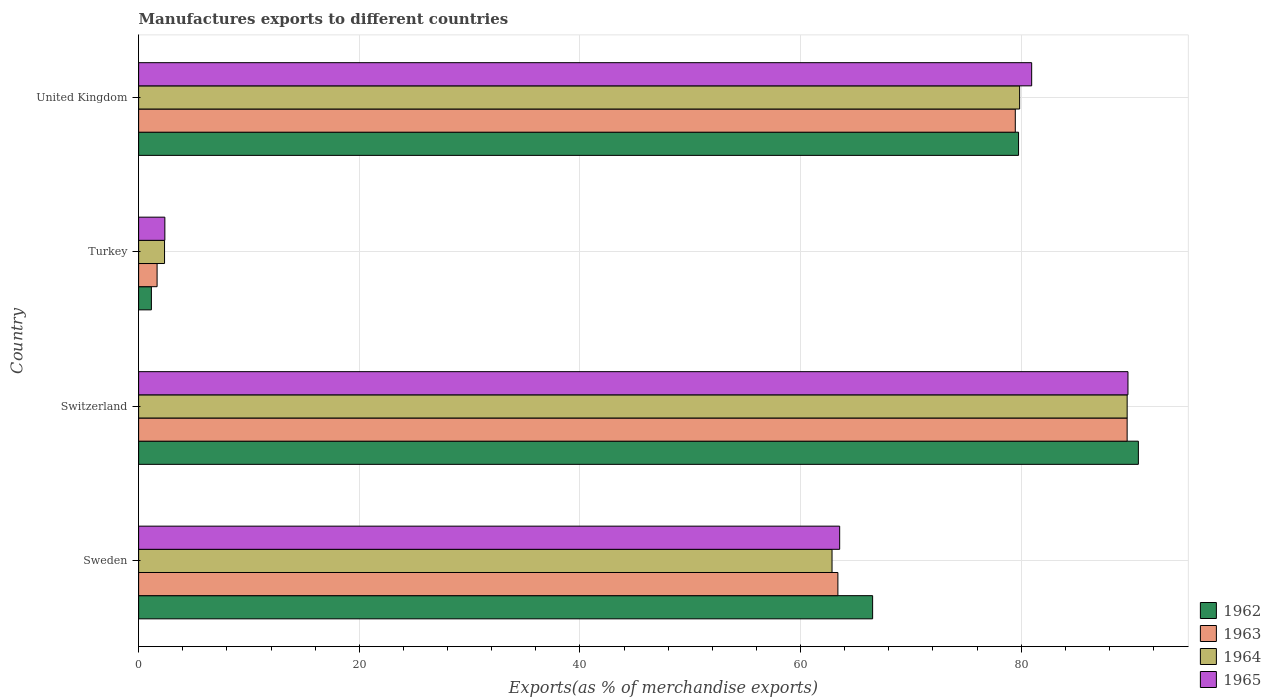How many different coloured bars are there?
Keep it short and to the point. 4. How many bars are there on the 1st tick from the top?
Ensure brevity in your answer.  4. How many bars are there on the 4th tick from the bottom?
Keep it short and to the point. 4. What is the label of the 4th group of bars from the top?
Offer a terse response. Sweden. In how many cases, is the number of bars for a given country not equal to the number of legend labels?
Provide a succinct answer. 0. What is the percentage of exports to different countries in 1965 in Switzerland?
Offer a very short reply. 89.68. Across all countries, what is the maximum percentage of exports to different countries in 1963?
Provide a short and direct response. 89.61. Across all countries, what is the minimum percentage of exports to different countries in 1962?
Your response must be concise. 1.16. In which country was the percentage of exports to different countries in 1965 maximum?
Provide a short and direct response. Switzerland. In which country was the percentage of exports to different countries in 1965 minimum?
Provide a short and direct response. Turkey. What is the total percentage of exports to different countries in 1964 in the graph?
Provide a succinct answer. 234.68. What is the difference between the percentage of exports to different countries in 1962 in Switzerland and that in United Kingdom?
Offer a very short reply. 10.86. What is the difference between the percentage of exports to different countries in 1965 in Turkey and the percentage of exports to different countries in 1962 in Sweden?
Ensure brevity in your answer.  -64.16. What is the average percentage of exports to different countries in 1964 per country?
Your response must be concise. 58.67. What is the difference between the percentage of exports to different countries in 1964 and percentage of exports to different countries in 1965 in Sweden?
Your answer should be very brief. -0.69. What is the ratio of the percentage of exports to different countries in 1965 in Sweden to that in United Kingdom?
Give a very brief answer. 0.78. What is the difference between the highest and the second highest percentage of exports to different countries in 1965?
Your answer should be very brief. 8.73. What is the difference between the highest and the lowest percentage of exports to different countries in 1964?
Ensure brevity in your answer.  87.26. Is the sum of the percentage of exports to different countries in 1962 in Turkey and United Kingdom greater than the maximum percentage of exports to different countries in 1964 across all countries?
Make the answer very short. No. Is it the case that in every country, the sum of the percentage of exports to different countries in 1963 and percentage of exports to different countries in 1964 is greater than the sum of percentage of exports to different countries in 1962 and percentage of exports to different countries in 1965?
Ensure brevity in your answer.  No. What does the 2nd bar from the top in Sweden represents?
Offer a very short reply. 1964. What does the 4th bar from the bottom in Turkey represents?
Provide a short and direct response. 1965. Are all the bars in the graph horizontal?
Your answer should be very brief. Yes. How many countries are there in the graph?
Your answer should be very brief. 4. What is the difference between two consecutive major ticks on the X-axis?
Provide a succinct answer. 20. Does the graph contain grids?
Your answer should be very brief. Yes. How many legend labels are there?
Offer a terse response. 4. What is the title of the graph?
Offer a very short reply. Manufactures exports to different countries. Does "1977" appear as one of the legend labels in the graph?
Your answer should be very brief. No. What is the label or title of the X-axis?
Your answer should be compact. Exports(as % of merchandise exports). What is the label or title of the Y-axis?
Ensure brevity in your answer.  Country. What is the Exports(as % of merchandise exports) of 1962 in Sweden?
Ensure brevity in your answer.  66.54. What is the Exports(as % of merchandise exports) in 1963 in Sweden?
Your answer should be very brief. 63.39. What is the Exports(as % of merchandise exports) in 1964 in Sweden?
Offer a terse response. 62.86. What is the Exports(as % of merchandise exports) of 1965 in Sweden?
Keep it short and to the point. 63.55. What is the Exports(as % of merchandise exports) of 1962 in Switzerland?
Make the answer very short. 90.63. What is the Exports(as % of merchandise exports) in 1963 in Switzerland?
Your answer should be compact. 89.61. What is the Exports(as % of merchandise exports) of 1964 in Switzerland?
Your response must be concise. 89.61. What is the Exports(as % of merchandise exports) in 1965 in Switzerland?
Your response must be concise. 89.68. What is the Exports(as % of merchandise exports) in 1962 in Turkey?
Provide a short and direct response. 1.16. What is the Exports(as % of merchandise exports) of 1963 in Turkey?
Ensure brevity in your answer.  1.67. What is the Exports(as % of merchandise exports) in 1964 in Turkey?
Offer a very short reply. 2.35. What is the Exports(as % of merchandise exports) of 1965 in Turkey?
Offer a very short reply. 2.38. What is the Exports(as % of merchandise exports) in 1962 in United Kingdom?
Your answer should be compact. 79.77. What is the Exports(as % of merchandise exports) of 1963 in United Kingdom?
Make the answer very short. 79.47. What is the Exports(as % of merchandise exports) in 1964 in United Kingdom?
Make the answer very short. 79.86. What is the Exports(as % of merchandise exports) in 1965 in United Kingdom?
Ensure brevity in your answer.  80.96. Across all countries, what is the maximum Exports(as % of merchandise exports) of 1962?
Keep it short and to the point. 90.63. Across all countries, what is the maximum Exports(as % of merchandise exports) of 1963?
Provide a short and direct response. 89.61. Across all countries, what is the maximum Exports(as % of merchandise exports) in 1964?
Keep it short and to the point. 89.61. Across all countries, what is the maximum Exports(as % of merchandise exports) in 1965?
Keep it short and to the point. 89.68. Across all countries, what is the minimum Exports(as % of merchandise exports) in 1962?
Offer a terse response. 1.16. Across all countries, what is the minimum Exports(as % of merchandise exports) of 1963?
Give a very brief answer. 1.67. Across all countries, what is the minimum Exports(as % of merchandise exports) in 1964?
Your answer should be very brief. 2.35. Across all countries, what is the minimum Exports(as % of merchandise exports) of 1965?
Keep it short and to the point. 2.38. What is the total Exports(as % of merchandise exports) in 1962 in the graph?
Your response must be concise. 238.09. What is the total Exports(as % of merchandise exports) in 1963 in the graph?
Provide a short and direct response. 234.14. What is the total Exports(as % of merchandise exports) in 1964 in the graph?
Make the answer very short. 234.68. What is the total Exports(as % of merchandise exports) of 1965 in the graph?
Offer a terse response. 236.57. What is the difference between the Exports(as % of merchandise exports) of 1962 in Sweden and that in Switzerland?
Make the answer very short. -24.09. What is the difference between the Exports(as % of merchandise exports) of 1963 in Sweden and that in Switzerland?
Your answer should be compact. -26.22. What is the difference between the Exports(as % of merchandise exports) in 1964 in Sweden and that in Switzerland?
Your response must be concise. -26.75. What is the difference between the Exports(as % of merchandise exports) of 1965 in Sweden and that in Switzerland?
Your response must be concise. -26.13. What is the difference between the Exports(as % of merchandise exports) in 1962 in Sweden and that in Turkey?
Offer a very short reply. 65.38. What is the difference between the Exports(as % of merchandise exports) of 1963 in Sweden and that in Turkey?
Provide a short and direct response. 61.72. What is the difference between the Exports(as % of merchandise exports) of 1964 in Sweden and that in Turkey?
Your answer should be very brief. 60.51. What is the difference between the Exports(as % of merchandise exports) in 1965 in Sweden and that in Turkey?
Ensure brevity in your answer.  61.17. What is the difference between the Exports(as % of merchandise exports) of 1962 in Sweden and that in United Kingdom?
Give a very brief answer. -13.23. What is the difference between the Exports(as % of merchandise exports) in 1963 in Sweden and that in United Kingdom?
Your answer should be very brief. -16.08. What is the difference between the Exports(as % of merchandise exports) of 1964 in Sweden and that in United Kingdom?
Provide a succinct answer. -17.01. What is the difference between the Exports(as % of merchandise exports) of 1965 in Sweden and that in United Kingdom?
Your answer should be very brief. -17.41. What is the difference between the Exports(as % of merchandise exports) in 1962 in Switzerland and that in Turkey?
Offer a very short reply. 89.47. What is the difference between the Exports(as % of merchandise exports) of 1963 in Switzerland and that in Turkey?
Provide a succinct answer. 87.94. What is the difference between the Exports(as % of merchandise exports) in 1964 in Switzerland and that in Turkey?
Your response must be concise. 87.26. What is the difference between the Exports(as % of merchandise exports) in 1965 in Switzerland and that in Turkey?
Provide a short and direct response. 87.31. What is the difference between the Exports(as % of merchandise exports) in 1962 in Switzerland and that in United Kingdom?
Your answer should be compact. 10.86. What is the difference between the Exports(as % of merchandise exports) of 1963 in Switzerland and that in United Kingdom?
Provide a succinct answer. 10.14. What is the difference between the Exports(as % of merchandise exports) in 1964 in Switzerland and that in United Kingdom?
Keep it short and to the point. 9.75. What is the difference between the Exports(as % of merchandise exports) in 1965 in Switzerland and that in United Kingdom?
Your answer should be compact. 8.73. What is the difference between the Exports(as % of merchandise exports) in 1962 in Turkey and that in United Kingdom?
Keep it short and to the point. -78.61. What is the difference between the Exports(as % of merchandise exports) in 1963 in Turkey and that in United Kingdom?
Keep it short and to the point. -77.8. What is the difference between the Exports(as % of merchandise exports) in 1964 in Turkey and that in United Kingdom?
Provide a succinct answer. -77.51. What is the difference between the Exports(as % of merchandise exports) of 1965 in Turkey and that in United Kingdom?
Give a very brief answer. -78.58. What is the difference between the Exports(as % of merchandise exports) in 1962 in Sweden and the Exports(as % of merchandise exports) in 1963 in Switzerland?
Give a very brief answer. -23.07. What is the difference between the Exports(as % of merchandise exports) of 1962 in Sweden and the Exports(as % of merchandise exports) of 1964 in Switzerland?
Offer a terse response. -23.07. What is the difference between the Exports(as % of merchandise exports) in 1962 in Sweden and the Exports(as % of merchandise exports) in 1965 in Switzerland?
Your response must be concise. -23.15. What is the difference between the Exports(as % of merchandise exports) of 1963 in Sweden and the Exports(as % of merchandise exports) of 1964 in Switzerland?
Your response must be concise. -26.22. What is the difference between the Exports(as % of merchandise exports) of 1963 in Sweden and the Exports(as % of merchandise exports) of 1965 in Switzerland?
Make the answer very short. -26.3. What is the difference between the Exports(as % of merchandise exports) in 1964 in Sweden and the Exports(as % of merchandise exports) in 1965 in Switzerland?
Offer a very short reply. -26.83. What is the difference between the Exports(as % of merchandise exports) of 1962 in Sweden and the Exports(as % of merchandise exports) of 1963 in Turkey?
Provide a succinct answer. 64.86. What is the difference between the Exports(as % of merchandise exports) in 1962 in Sweden and the Exports(as % of merchandise exports) in 1964 in Turkey?
Make the answer very short. 64.19. What is the difference between the Exports(as % of merchandise exports) in 1962 in Sweden and the Exports(as % of merchandise exports) in 1965 in Turkey?
Provide a succinct answer. 64.16. What is the difference between the Exports(as % of merchandise exports) of 1963 in Sweden and the Exports(as % of merchandise exports) of 1964 in Turkey?
Your answer should be very brief. 61.04. What is the difference between the Exports(as % of merchandise exports) in 1963 in Sweden and the Exports(as % of merchandise exports) in 1965 in Turkey?
Provide a succinct answer. 61.01. What is the difference between the Exports(as % of merchandise exports) of 1964 in Sweden and the Exports(as % of merchandise exports) of 1965 in Turkey?
Offer a terse response. 60.48. What is the difference between the Exports(as % of merchandise exports) in 1962 in Sweden and the Exports(as % of merchandise exports) in 1963 in United Kingdom?
Your response must be concise. -12.93. What is the difference between the Exports(as % of merchandise exports) of 1962 in Sweden and the Exports(as % of merchandise exports) of 1964 in United Kingdom?
Your response must be concise. -13.33. What is the difference between the Exports(as % of merchandise exports) of 1962 in Sweden and the Exports(as % of merchandise exports) of 1965 in United Kingdom?
Your answer should be very brief. -14.42. What is the difference between the Exports(as % of merchandise exports) of 1963 in Sweden and the Exports(as % of merchandise exports) of 1964 in United Kingdom?
Your response must be concise. -16.47. What is the difference between the Exports(as % of merchandise exports) in 1963 in Sweden and the Exports(as % of merchandise exports) in 1965 in United Kingdom?
Make the answer very short. -17.57. What is the difference between the Exports(as % of merchandise exports) in 1964 in Sweden and the Exports(as % of merchandise exports) in 1965 in United Kingdom?
Offer a very short reply. -18.1. What is the difference between the Exports(as % of merchandise exports) of 1962 in Switzerland and the Exports(as % of merchandise exports) of 1963 in Turkey?
Provide a short and direct response. 88.95. What is the difference between the Exports(as % of merchandise exports) in 1962 in Switzerland and the Exports(as % of merchandise exports) in 1964 in Turkey?
Your response must be concise. 88.28. What is the difference between the Exports(as % of merchandise exports) of 1962 in Switzerland and the Exports(as % of merchandise exports) of 1965 in Turkey?
Your answer should be compact. 88.25. What is the difference between the Exports(as % of merchandise exports) in 1963 in Switzerland and the Exports(as % of merchandise exports) in 1964 in Turkey?
Your answer should be very brief. 87.26. What is the difference between the Exports(as % of merchandise exports) in 1963 in Switzerland and the Exports(as % of merchandise exports) in 1965 in Turkey?
Keep it short and to the point. 87.23. What is the difference between the Exports(as % of merchandise exports) of 1964 in Switzerland and the Exports(as % of merchandise exports) of 1965 in Turkey?
Provide a succinct answer. 87.23. What is the difference between the Exports(as % of merchandise exports) of 1962 in Switzerland and the Exports(as % of merchandise exports) of 1963 in United Kingdom?
Ensure brevity in your answer.  11.16. What is the difference between the Exports(as % of merchandise exports) in 1962 in Switzerland and the Exports(as % of merchandise exports) in 1964 in United Kingdom?
Give a very brief answer. 10.76. What is the difference between the Exports(as % of merchandise exports) of 1962 in Switzerland and the Exports(as % of merchandise exports) of 1965 in United Kingdom?
Keep it short and to the point. 9.67. What is the difference between the Exports(as % of merchandise exports) of 1963 in Switzerland and the Exports(as % of merchandise exports) of 1964 in United Kingdom?
Your response must be concise. 9.75. What is the difference between the Exports(as % of merchandise exports) of 1963 in Switzerland and the Exports(as % of merchandise exports) of 1965 in United Kingdom?
Ensure brevity in your answer.  8.65. What is the difference between the Exports(as % of merchandise exports) in 1964 in Switzerland and the Exports(as % of merchandise exports) in 1965 in United Kingdom?
Provide a succinct answer. 8.66. What is the difference between the Exports(as % of merchandise exports) in 1962 in Turkey and the Exports(as % of merchandise exports) in 1963 in United Kingdom?
Your response must be concise. -78.31. What is the difference between the Exports(as % of merchandise exports) in 1962 in Turkey and the Exports(as % of merchandise exports) in 1964 in United Kingdom?
Provide a succinct answer. -78.71. What is the difference between the Exports(as % of merchandise exports) in 1962 in Turkey and the Exports(as % of merchandise exports) in 1965 in United Kingdom?
Your answer should be very brief. -79.8. What is the difference between the Exports(as % of merchandise exports) in 1963 in Turkey and the Exports(as % of merchandise exports) in 1964 in United Kingdom?
Keep it short and to the point. -78.19. What is the difference between the Exports(as % of merchandise exports) of 1963 in Turkey and the Exports(as % of merchandise exports) of 1965 in United Kingdom?
Your answer should be very brief. -79.28. What is the difference between the Exports(as % of merchandise exports) in 1964 in Turkey and the Exports(as % of merchandise exports) in 1965 in United Kingdom?
Your answer should be compact. -78.61. What is the average Exports(as % of merchandise exports) of 1962 per country?
Ensure brevity in your answer.  59.52. What is the average Exports(as % of merchandise exports) in 1963 per country?
Give a very brief answer. 58.54. What is the average Exports(as % of merchandise exports) in 1964 per country?
Your answer should be very brief. 58.67. What is the average Exports(as % of merchandise exports) of 1965 per country?
Your answer should be very brief. 59.14. What is the difference between the Exports(as % of merchandise exports) in 1962 and Exports(as % of merchandise exports) in 1963 in Sweden?
Your response must be concise. 3.15. What is the difference between the Exports(as % of merchandise exports) of 1962 and Exports(as % of merchandise exports) of 1964 in Sweden?
Your answer should be very brief. 3.68. What is the difference between the Exports(as % of merchandise exports) in 1962 and Exports(as % of merchandise exports) in 1965 in Sweden?
Ensure brevity in your answer.  2.99. What is the difference between the Exports(as % of merchandise exports) in 1963 and Exports(as % of merchandise exports) in 1964 in Sweden?
Offer a very short reply. 0.53. What is the difference between the Exports(as % of merchandise exports) of 1963 and Exports(as % of merchandise exports) of 1965 in Sweden?
Ensure brevity in your answer.  -0.16. What is the difference between the Exports(as % of merchandise exports) of 1964 and Exports(as % of merchandise exports) of 1965 in Sweden?
Your answer should be very brief. -0.69. What is the difference between the Exports(as % of merchandise exports) of 1962 and Exports(as % of merchandise exports) of 1963 in Switzerland?
Keep it short and to the point. 1.02. What is the difference between the Exports(as % of merchandise exports) in 1962 and Exports(as % of merchandise exports) in 1964 in Switzerland?
Your answer should be compact. 1.02. What is the difference between the Exports(as % of merchandise exports) of 1962 and Exports(as % of merchandise exports) of 1965 in Switzerland?
Keep it short and to the point. 0.94. What is the difference between the Exports(as % of merchandise exports) in 1963 and Exports(as % of merchandise exports) in 1964 in Switzerland?
Keep it short and to the point. -0. What is the difference between the Exports(as % of merchandise exports) of 1963 and Exports(as % of merchandise exports) of 1965 in Switzerland?
Provide a short and direct response. -0.07. What is the difference between the Exports(as % of merchandise exports) of 1964 and Exports(as % of merchandise exports) of 1965 in Switzerland?
Offer a very short reply. -0.07. What is the difference between the Exports(as % of merchandise exports) of 1962 and Exports(as % of merchandise exports) of 1963 in Turkey?
Provide a short and direct response. -0.52. What is the difference between the Exports(as % of merchandise exports) in 1962 and Exports(as % of merchandise exports) in 1964 in Turkey?
Your response must be concise. -1.19. What is the difference between the Exports(as % of merchandise exports) of 1962 and Exports(as % of merchandise exports) of 1965 in Turkey?
Keep it short and to the point. -1.22. What is the difference between the Exports(as % of merchandise exports) in 1963 and Exports(as % of merchandise exports) in 1964 in Turkey?
Your answer should be very brief. -0.68. What is the difference between the Exports(as % of merchandise exports) in 1963 and Exports(as % of merchandise exports) in 1965 in Turkey?
Make the answer very short. -0.7. What is the difference between the Exports(as % of merchandise exports) in 1964 and Exports(as % of merchandise exports) in 1965 in Turkey?
Make the answer very short. -0.03. What is the difference between the Exports(as % of merchandise exports) in 1962 and Exports(as % of merchandise exports) in 1963 in United Kingdom?
Make the answer very short. 0.29. What is the difference between the Exports(as % of merchandise exports) of 1962 and Exports(as % of merchandise exports) of 1964 in United Kingdom?
Your answer should be compact. -0.1. What is the difference between the Exports(as % of merchandise exports) of 1962 and Exports(as % of merchandise exports) of 1965 in United Kingdom?
Keep it short and to the point. -1.19. What is the difference between the Exports(as % of merchandise exports) in 1963 and Exports(as % of merchandise exports) in 1964 in United Kingdom?
Offer a very short reply. -0.39. What is the difference between the Exports(as % of merchandise exports) in 1963 and Exports(as % of merchandise exports) in 1965 in United Kingdom?
Make the answer very short. -1.48. What is the difference between the Exports(as % of merchandise exports) in 1964 and Exports(as % of merchandise exports) in 1965 in United Kingdom?
Provide a short and direct response. -1.09. What is the ratio of the Exports(as % of merchandise exports) of 1962 in Sweden to that in Switzerland?
Your answer should be very brief. 0.73. What is the ratio of the Exports(as % of merchandise exports) of 1963 in Sweden to that in Switzerland?
Keep it short and to the point. 0.71. What is the ratio of the Exports(as % of merchandise exports) of 1964 in Sweden to that in Switzerland?
Ensure brevity in your answer.  0.7. What is the ratio of the Exports(as % of merchandise exports) of 1965 in Sweden to that in Switzerland?
Provide a succinct answer. 0.71. What is the ratio of the Exports(as % of merchandise exports) in 1962 in Sweden to that in Turkey?
Keep it short and to the point. 57.54. What is the ratio of the Exports(as % of merchandise exports) of 1963 in Sweden to that in Turkey?
Your answer should be very brief. 37.87. What is the ratio of the Exports(as % of merchandise exports) in 1964 in Sweden to that in Turkey?
Your response must be concise. 26.75. What is the ratio of the Exports(as % of merchandise exports) of 1965 in Sweden to that in Turkey?
Keep it short and to the point. 26.73. What is the ratio of the Exports(as % of merchandise exports) of 1962 in Sweden to that in United Kingdom?
Keep it short and to the point. 0.83. What is the ratio of the Exports(as % of merchandise exports) of 1963 in Sweden to that in United Kingdom?
Provide a succinct answer. 0.8. What is the ratio of the Exports(as % of merchandise exports) of 1964 in Sweden to that in United Kingdom?
Keep it short and to the point. 0.79. What is the ratio of the Exports(as % of merchandise exports) of 1965 in Sweden to that in United Kingdom?
Your answer should be compact. 0.79. What is the ratio of the Exports(as % of merchandise exports) in 1962 in Switzerland to that in Turkey?
Your answer should be very brief. 78.37. What is the ratio of the Exports(as % of merchandise exports) of 1963 in Switzerland to that in Turkey?
Your answer should be compact. 53.54. What is the ratio of the Exports(as % of merchandise exports) in 1964 in Switzerland to that in Turkey?
Make the answer very short. 38.13. What is the ratio of the Exports(as % of merchandise exports) of 1965 in Switzerland to that in Turkey?
Give a very brief answer. 37.72. What is the ratio of the Exports(as % of merchandise exports) of 1962 in Switzerland to that in United Kingdom?
Provide a short and direct response. 1.14. What is the ratio of the Exports(as % of merchandise exports) of 1963 in Switzerland to that in United Kingdom?
Provide a succinct answer. 1.13. What is the ratio of the Exports(as % of merchandise exports) in 1964 in Switzerland to that in United Kingdom?
Offer a terse response. 1.12. What is the ratio of the Exports(as % of merchandise exports) of 1965 in Switzerland to that in United Kingdom?
Your answer should be very brief. 1.11. What is the ratio of the Exports(as % of merchandise exports) of 1962 in Turkey to that in United Kingdom?
Keep it short and to the point. 0.01. What is the ratio of the Exports(as % of merchandise exports) in 1963 in Turkey to that in United Kingdom?
Ensure brevity in your answer.  0.02. What is the ratio of the Exports(as % of merchandise exports) of 1964 in Turkey to that in United Kingdom?
Give a very brief answer. 0.03. What is the ratio of the Exports(as % of merchandise exports) in 1965 in Turkey to that in United Kingdom?
Offer a terse response. 0.03. What is the difference between the highest and the second highest Exports(as % of merchandise exports) of 1962?
Provide a short and direct response. 10.86. What is the difference between the highest and the second highest Exports(as % of merchandise exports) of 1963?
Make the answer very short. 10.14. What is the difference between the highest and the second highest Exports(as % of merchandise exports) in 1964?
Offer a very short reply. 9.75. What is the difference between the highest and the second highest Exports(as % of merchandise exports) of 1965?
Offer a terse response. 8.73. What is the difference between the highest and the lowest Exports(as % of merchandise exports) in 1962?
Make the answer very short. 89.47. What is the difference between the highest and the lowest Exports(as % of merchandise exports) of 1963?
Provide a short and direct response. 87.94. What is the difference between the highest and the lowest Exports(as % of merchandise exports) in 1964?
Ensure brevity in your answer.  87.26. What is the difference between the highest and the lowest Exports(as % of merchandise exports) of 1965?
Offer a very short reply. 87.31. 